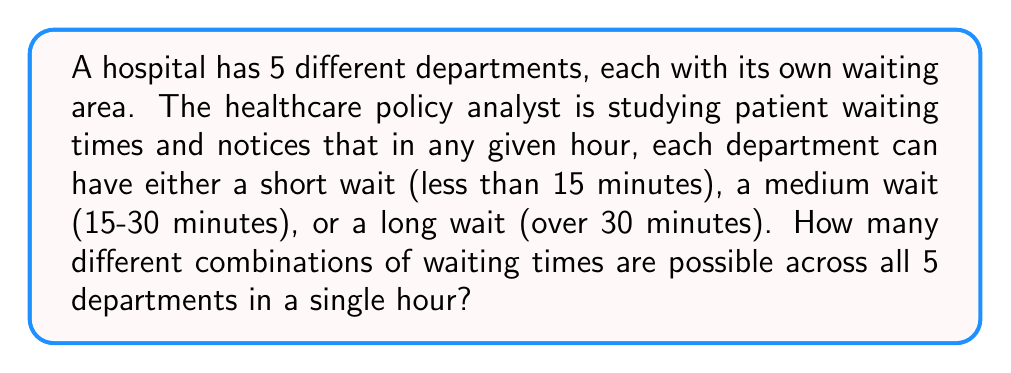Help me with this question. Let's approach this step-by-step:

1) For each department, there are 3 possible waiting time categories:
   - Short wait
   - Medium wait
   - Long wait

2) We need to determine how many ways we can assign these 3 possibilities to 5 departments.

3) This is a classic example of the multiplication principle in combinatorics. When we have independent choices, we multiply the number of options for each choice.

4) In this case, for each department, we have 3 choices, and we're making this choice 5 times (once for each department).

5) Therefore, the total number of possible combinations is:

   $$ 3 \times 3 \times 3 \times 3 \times 3 = 3^5 $$

6) Let's calculate this:

   $$ 3^5 = 3 \times 3 \times 3 \times 3 \times 3 = 243 $$

Thus, there are 243 different possible combinations of waiting times across the 5 departments in a single hour.
Answer: 243 